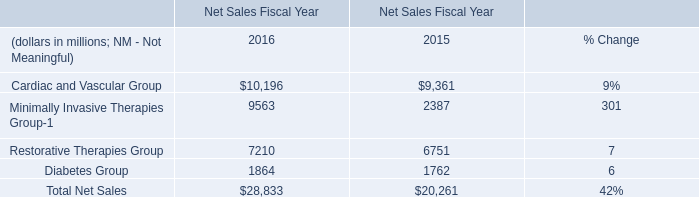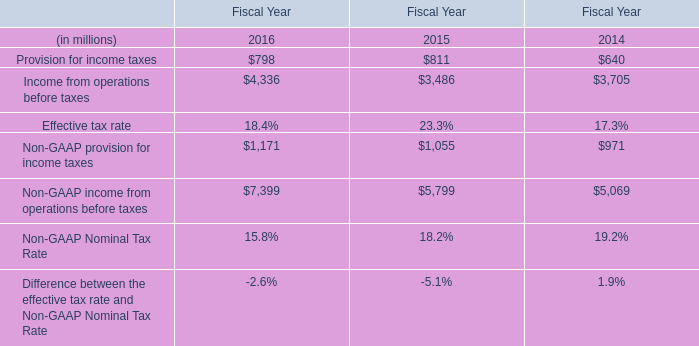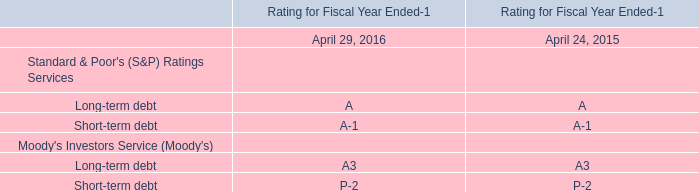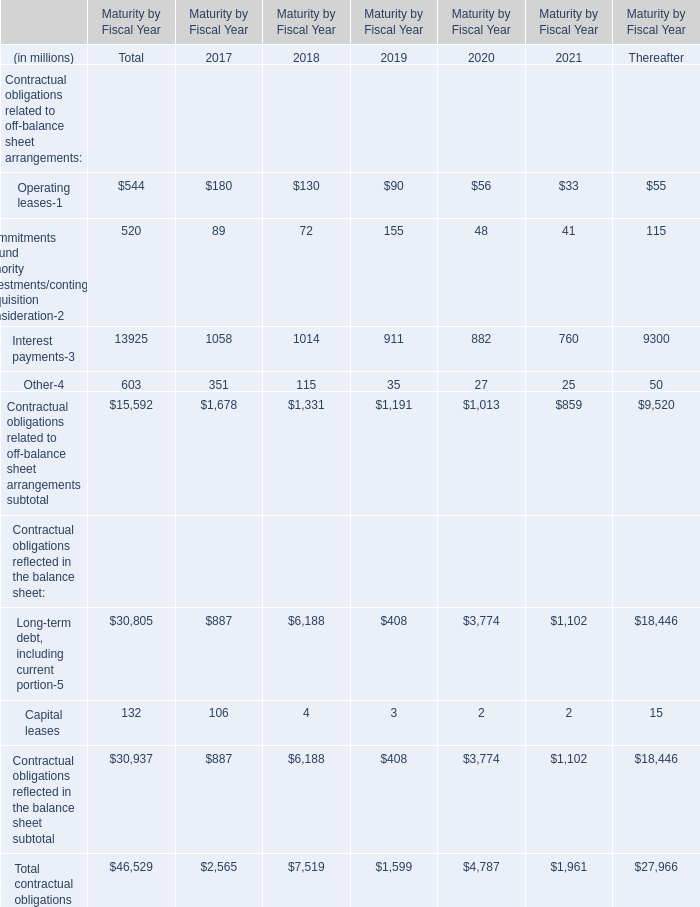What is the growing rate of Interest payments in the year with the most Long-term debt, including current portion ? (in %) 
Computations: ((1014 - 1058) / 1058)
Answer: -0.04159. 